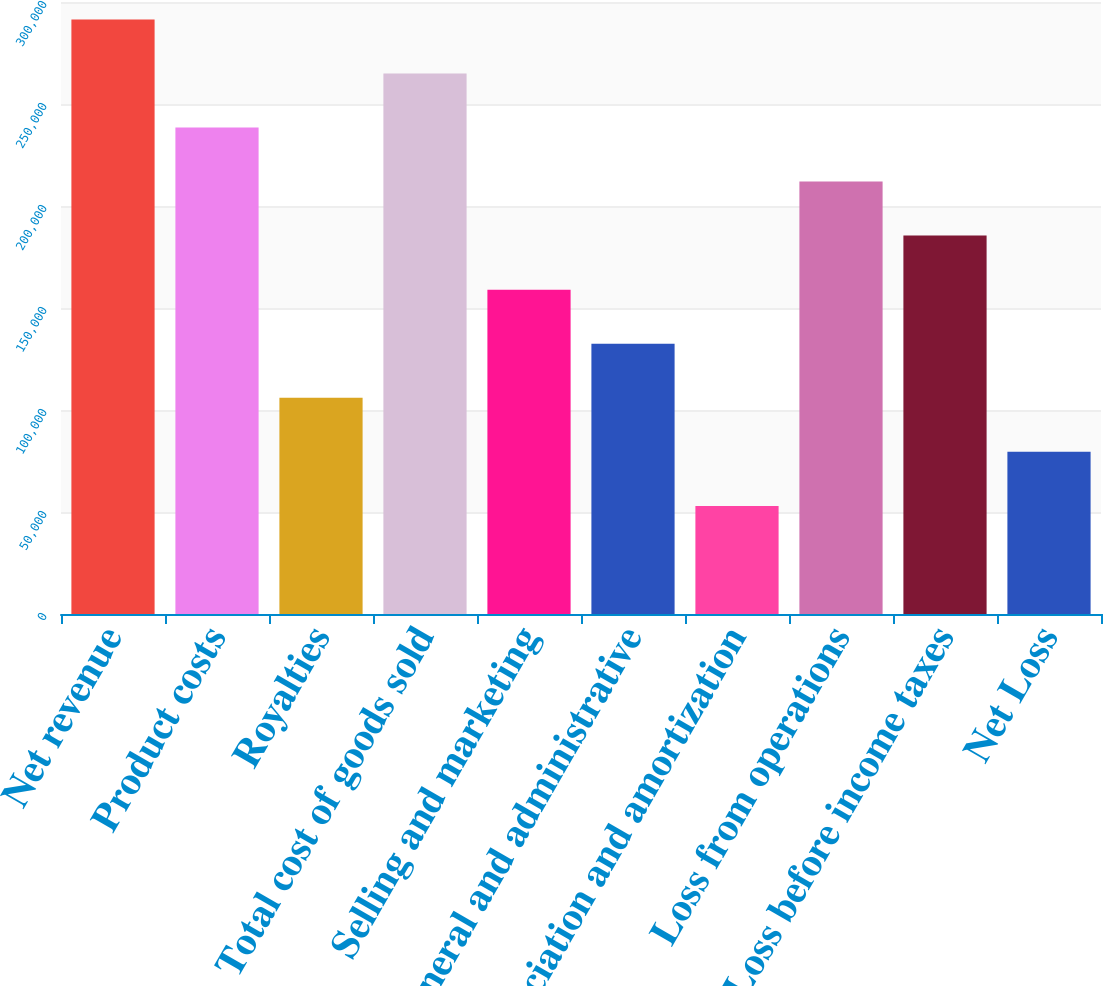<chart> <loc_0><loc_0><loc_500><loc_500><bar_chart><fcel>Net revenue<fcel>Product costs<fcel>Royalties<fcel>Total cost of goods sold<fcel>Selling and marketing<fcel>General and administrative<fcel>Depreciation and amortization<fcel>Loss from operations<fcel>Loss before income taxes<fcel>Net Loss<nl><fcel>291479<fcel>238483<fcel>105993<fcel>264981<fcel>158989<fcel>132491<fcel>52996.5<fcel>211985<fcel>185487<fcel>79494.6<nl></chart> 